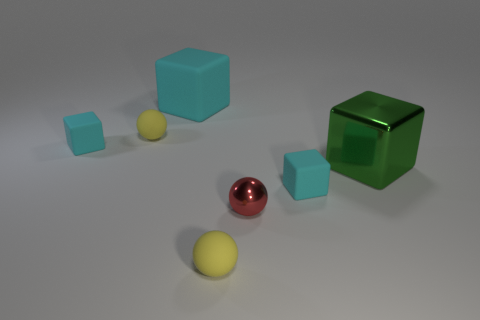Subtract all cyan cubes. How many were subtracted if there are1cyan cubes left? 2 Subtract all cyan blocks. How many blocks are left? 1 Subtract all yellow balls. How many balls are left? 1 Subtract 1 balls. How many balls are left? 2 Add 3 tiny blocks. How many objects exist? 10 Subtract 0 gray cylinders. How many objects are left? 7 Subtract all spheres. How many objects are left? 4 Subtract all purple cubes. Subtract all green cylinders. How many cubes are left? 4 Subtract all gray balls. How many purple cubes are left? 0 Subtract all red metallic spheres. Subtract all balls. How many objects are left? 3 